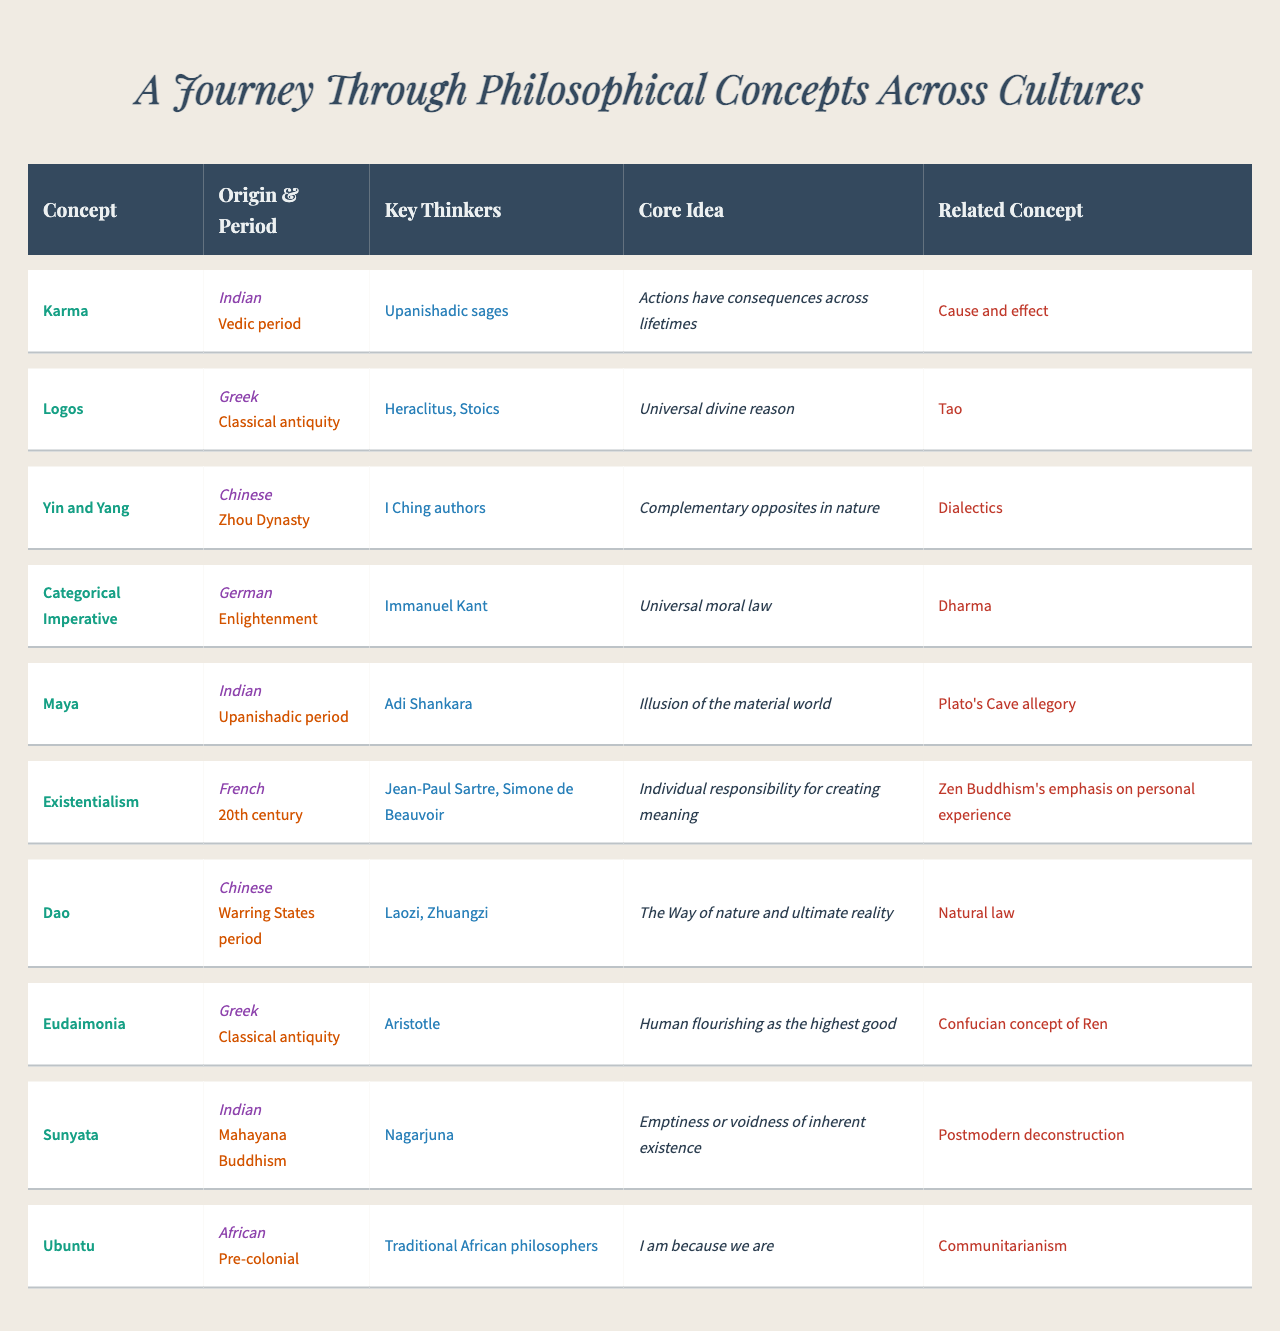What philosophical concept originated in the Zhou Dynasty? Looking at the table, the concept listed under the Zhou Dynasty is "Yin and Yang."
Answer: Yin and Yang Who is the key thinker associated with Existentialism? In the table, the key thinkers for Existentialism are Jean-Paul Sartre and Simone de Beauvoir.
Answer: Jean-Paul Sartre and Simone de Beauvoir Is "Karma" related to Western philosophy? The table shows that the related Western concept for Karma is "Cause and effect," suggesting a connection to Western philosophy.
Answer: Yes Which two concepts share a similar core idea of universal law or principle? The table indicates that "Categorical Imperative" (universal moral law) and "Dao" (The Way of nature) relate to universal principles.
Answer: Categorical Imperative and Dao What is the historical period of the concept "Eudaimonia"? The table indicates that the historical period for Eudaimonia is "Classical antiquity."
Answer: Classical antiquity How many Indian philosophical concepts are listed in the table? There are three concepts originating from Indian philosophy: "Karma," "Maya," and "Sunyata," which can be counted from the table.
Answer: Three Which cultural origin has the key thinker Adi Shankara associated with it? According to the table, Adi Shankara is associated with the Indian culture.
Answer: Indian What is the core idea of the philosophical concept "Dao"? The table lists the core idea of Dao as "The Way of nature and ultimate reality."
Answer: The Way of nature and ultimate reality Which concept relates to the idea of "I am because we are"? The table associates the core idea "I am because we are" with the concept "Ubuntu."
Answer: Ubuntu What is the primary difference in the historical periods of "Karma" and "Sunyata"? The historical period for Karma is the "Vedic period," while for Sunyata, it is "Mahayana Buddhism." Therefore, the difference is that they belong to different periods of Indian philosophy.
Answer: They belong to different periods Which concepts illustrate the idea of complementary opposites? The table lists "Yin and Yang" as illustrating the idea of complementary opposites in nature.
Answer: Yin and Yang How does the Chinese philosophical concept of "Dao" compare with Western natural law? The table connects Dao, which embodies the "Way of nature," with Western natural law, showing a parallel in understanding nature in both traditions.
Answer: They are comparable 